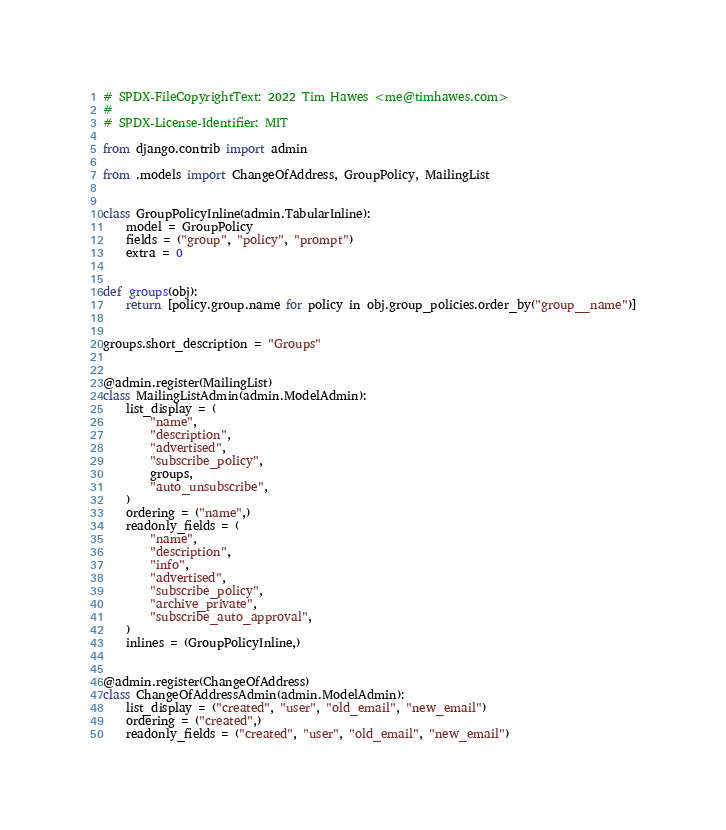<code> <loc_0><loc_0><loc_500><loc_500><_Python_># SPDX-FileCopyrightText: 2022 Tim Hawes <me@timhawes.com>
#
# SPDX-License-Identifier: MIT

from django.contrib import admin

from .models import ChangeOfAddress, GroupPolicy, MailingList


class GroupPolicyInline(admin.TabularInline):
    model = GroupPolicy
    fields = ("group", "policy", "prompt")
    extra = 0


def groups(obj):
    return [policy.group.name for policy in obj.group_policies.order_by("group__name")]


groups.short_description = "Groups"


@admin.register(MailingList)
class MailingListAdmin(admin.ModelAdmin):
    list_display = (
        "name",
        "description",
        "advertised",
        "subscribe_policy",
        groups,
        "auto_unsubscribe",
    )
    ordering = ("name",)
    readonly_fields = (
        "name",
        "description",
        "info",
        "advertised",
        "subscribe_policy",
        "archive_private",
        "subscribe_auto_approval",
    )
    inlines = (GroupPolicyInline,)


@admin.register(ChangeOfAddress)
class ChangeOfAddressAdmin(admin.ModelAdmin):
    list_display = ("created", "user", "old_email", "new_email")
    ordering = ("created",)
    readonly_fields = ("created", "user", "old_email", "new_email")
</code> 